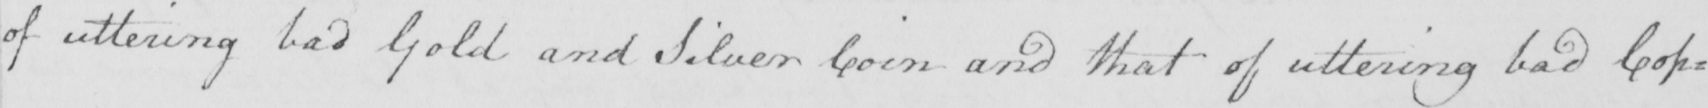What text is written in this handwritten line? of uttering bad Gold and Silver Coin and that of uttering bad Cop= 